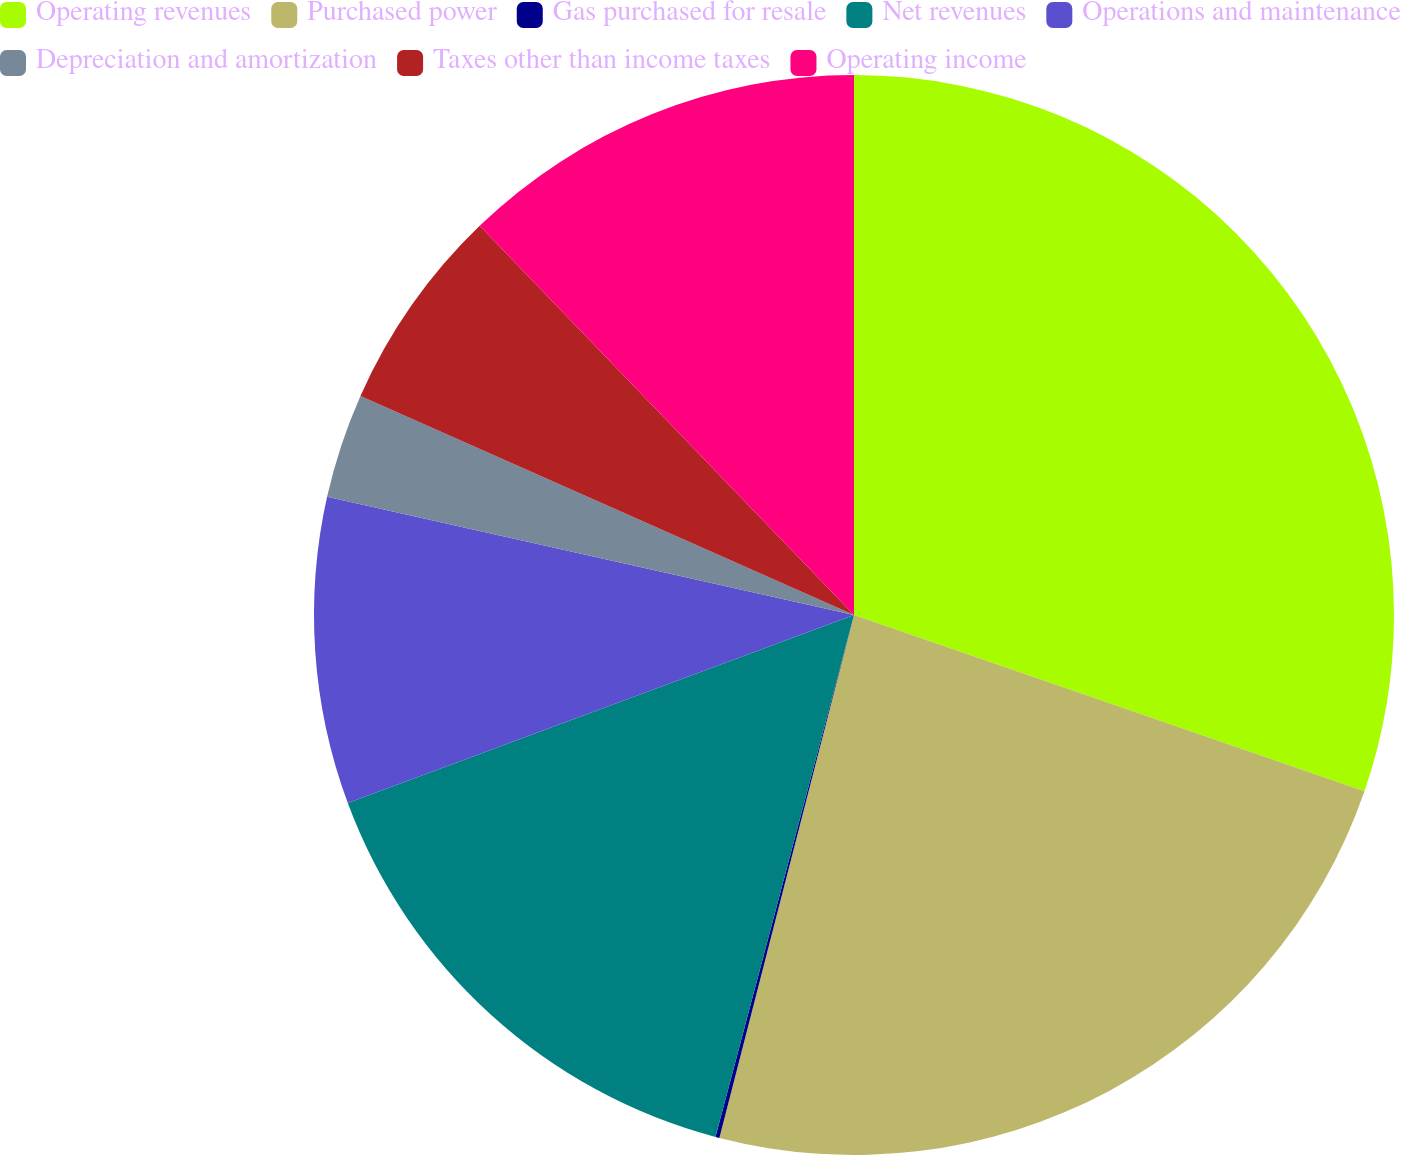Convert chart. <chart><loc_0><loc_0><loc_500><loc_500><pie_chart><fcel>Operating revenues<fcel>Purchased power<fcel>Gas purchased for resale<fcel>Net revenues<fcel>Operations and maintenance<fcel>Depreciation and amortization<fcel>Taxes other than income taxes<fcel>Operating income<nl><fcel>30.29%<fcel>23.72%<fcel>0.12%<fcel>15.21%<fcel>9.17%<fcel>3.14%<fcel>6.16%<fcel>12.19%<nl></chart> 